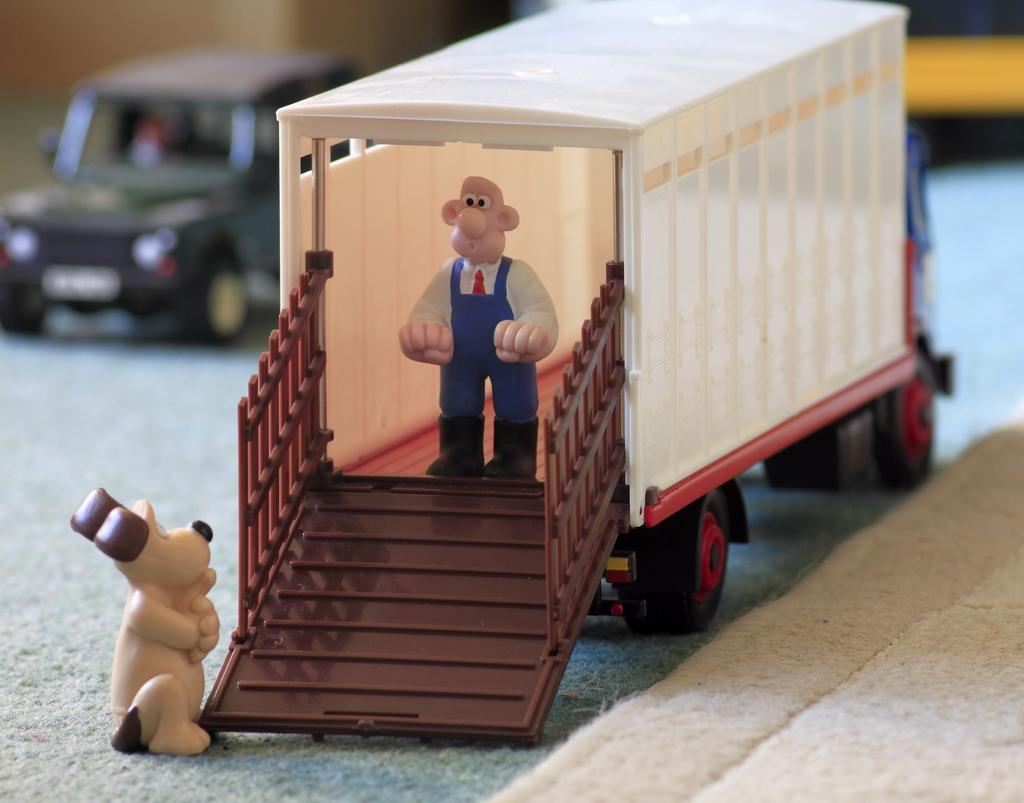How would you summarize this image in a sentence or two? Here we can see toy vehicles on the platform and there is a toy person in the truck standing and there is a toy dog at the vehicle door. 